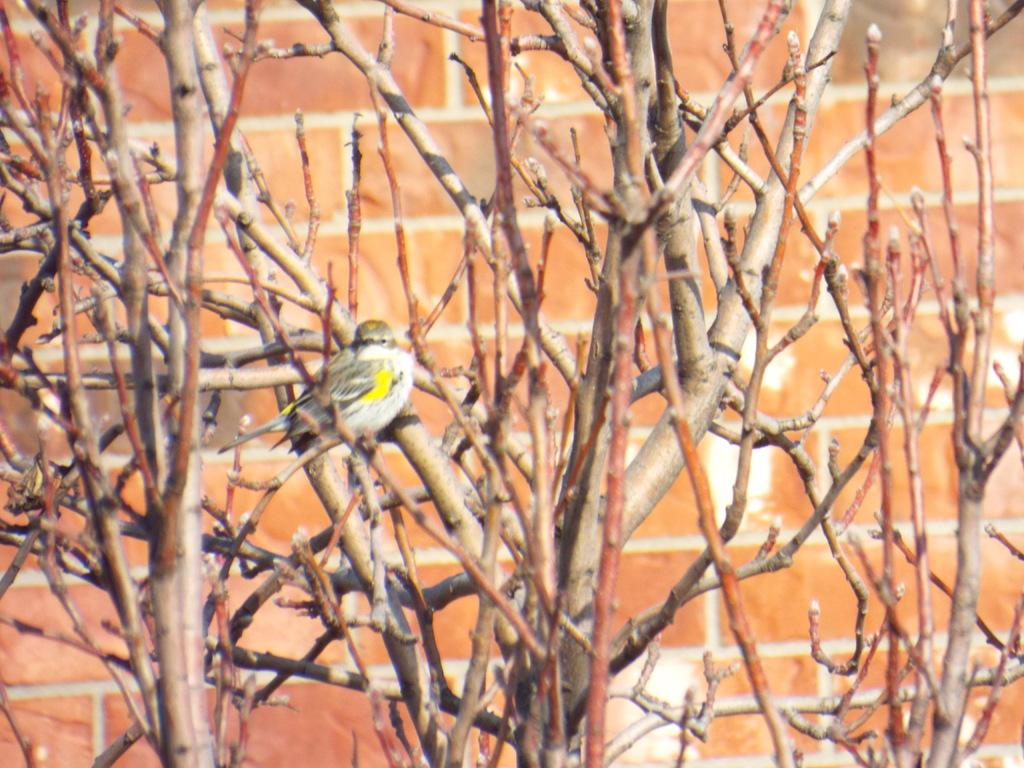What type of animal can be seen in the image? There is a bird in the image. Where is the bird located? The bird is on a tree. What is the material of the wall visible in the image? The wall has red bricks. What type of cookware is the bird using in the image? There is no cookware or cooking activity present in the image. Is the bird taking a bath in the image? There is no indication of the bird taking a bath in the image. 